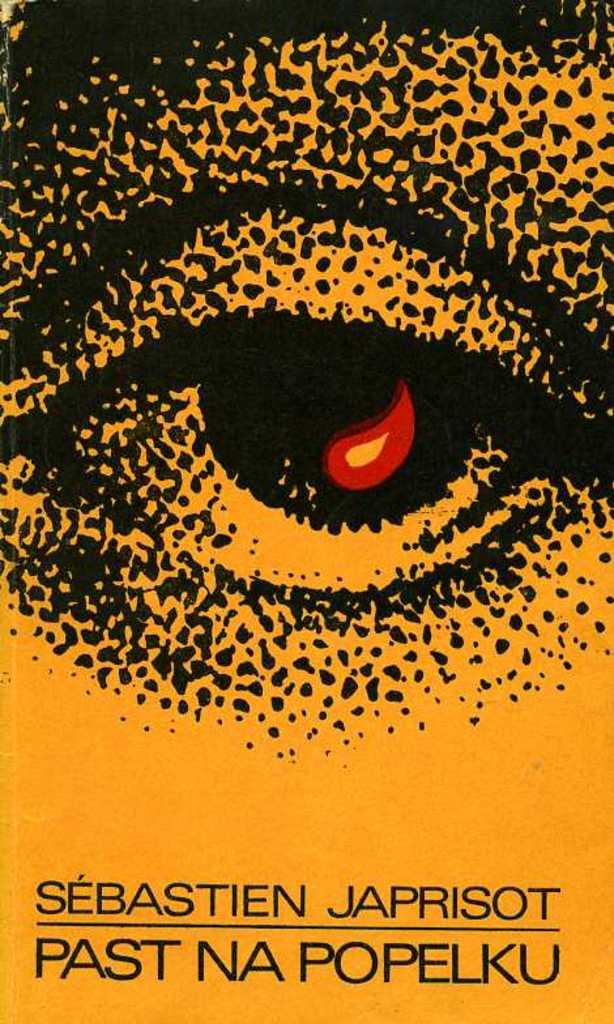<image>
Provide a brief description of the given image. A drawing of an eye that has the name of Sebastien Japrisot on it as well. 